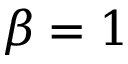Convert formula to latex. <formula><loc_0><loc_0><loc_500><loc_500>\beta = 1</formula> 